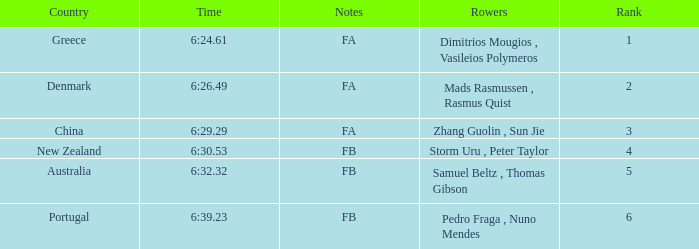What nation has a ranking below 6, a timing of 6:3 Australia. 